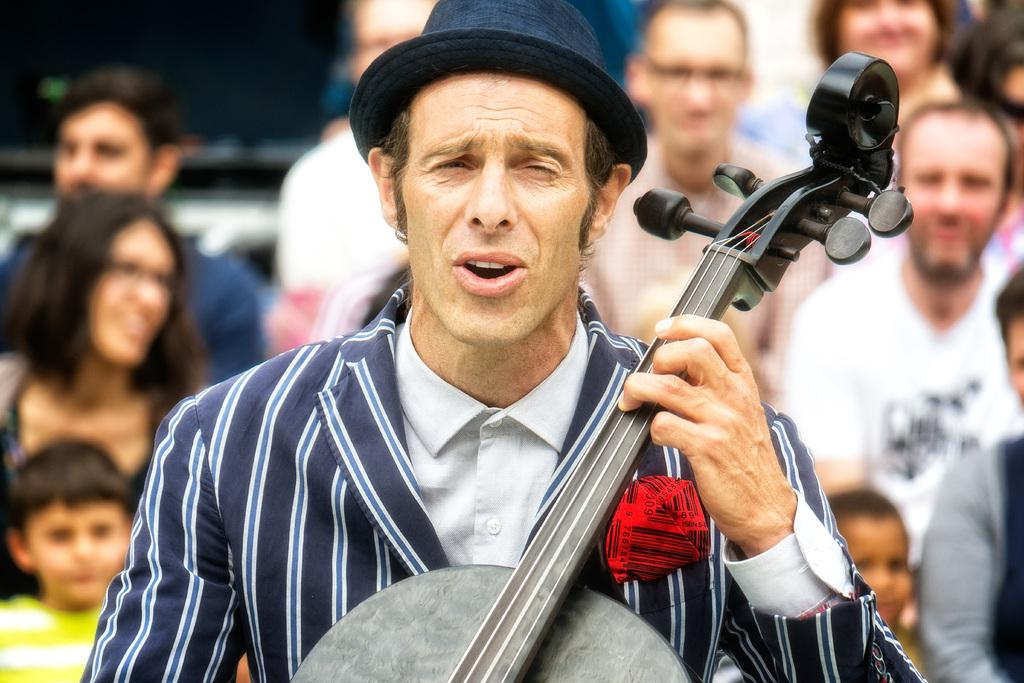What is the main subject in the foreground of the image? There is a person playing a musical instrument in the foreground. What can be seen in the background of the image? There is a group of people on the road in the background. Can you determine the time of day the image was taken? The image is likely taken during the day, as there is no indication of darkness or artificial lighting. What type of jewel is being worn by the person playing the musical instrument? There is no indication of any jewelry being worn by the person playing the musical instrument in the image. How many bananas can be seen in the image? There are no bananas present in the image. 